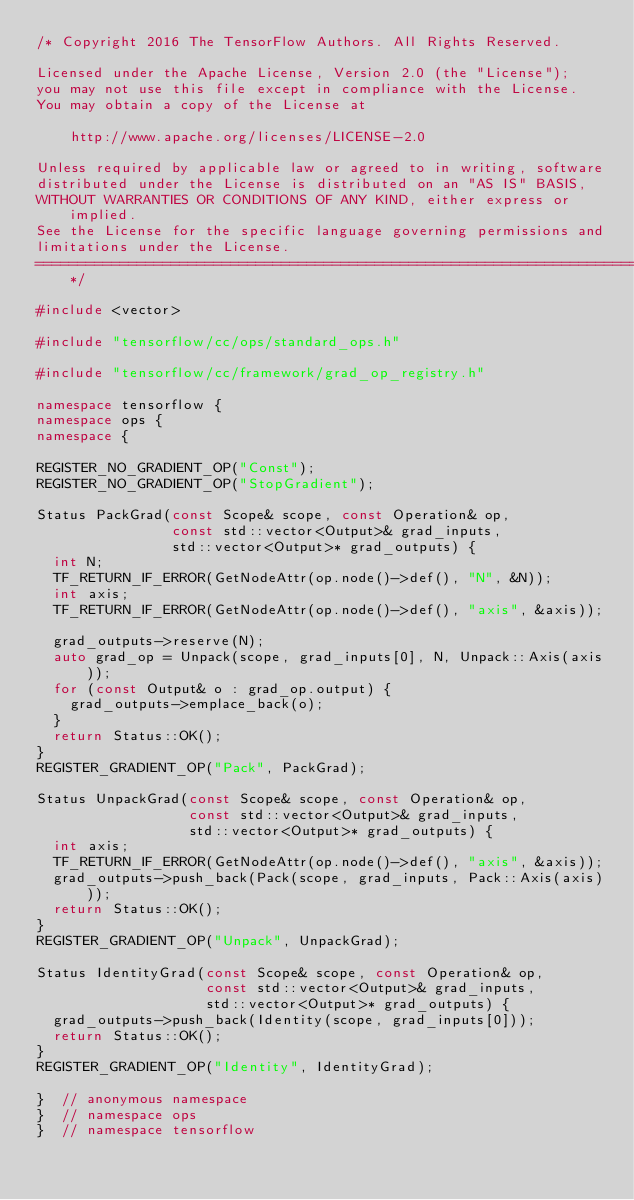<code> <loc_0><loc_0><loc_500><loc_500><_C++_>/* Copyright 2016 The TensorFlow Authors. All Rights Reserved.

Licensed under the Apache License, Version 2.0 (the "License");
you may not use this file except in compliance with the License.
You may obtain a copy of the License at

    http://www.apache.org/licenses/LICENSE-2.0

Unless required by applicable law or agreed to in writing, software
distributed under the License is distributed on an "AS IS" BASIS,
WITHOUT WARRANTIES OR CONDITIONS OF ANY KIND, either express or implied.
See the License for the specific language governing permissions and
limitations under the License.
==============================================================================*/

#include <vector>

#include "tensorflow/cc/ops/standard_ops.h"

#include "tensorflow/cc/framework/grad_op_registry.h"

namespace tensorflow {
namespace ops {
namespace {

REGISTER_NO_GRADIENT_OP("Const");
REGISTER_NO_GRADIENT_OP("StopGradient");

Status PackGrad(const Scope& scope, const Operation& op,
                const std::vector<Output>& grad_inputs,
                std::vector<Output>* grad_outputs) {
  int N;
  TF_RETURN_IF_ERROR(GetNodeAttr(op.node()->def(), "N", &N));
  int axis;
  TF_RETURN_IF_ERROR(GetNodeAttr(op.node()->def(), "axis", &axis));

  grad_outputs->reserve(N);
  auto grad_op = Unpack(scope, grad_inputs[0], N, Unpack::Axis(axis));
  for (const Output& o : grad_op.output) {
    grad_outputs->emplace_back(o);
  }
  return Status::OK();
}
REGISTER_GRADIENT_OP("Pack", PackGrad);

Status UnpackGrad(const Scope& scope, const Operation& op,
                  const std::vector<Output>& grad_inputs,
                  std::vector<Output>* grad_outputs) {
  int axis;
  TF_RETURN_IF_ERROR(GetNodeAttr(op.node()->def(), "axis", &axis));
  grad_outputs->push_back(Pack(scope, grad_inputs, Pack::Axis(axis)));
  return Status::OK();
}
REGISTER_GRADIENT_OP("Unpack", UnpackGrad);

Status IdentityGrad(const Scope& scope, const Operation& op,
                    const std::vector<Output>& grad_inputs,
                    std::vector<Output>* grad_outputs) {
  grad_outputs->push_back(Identity(scope, grad_inputs[0]));
  return Status::OK();
}
REGISTER_GRADIENT_OP("Identity", IdentityGrad);

}  // anonymous namespace
}  // namespace ops
}  // namespace tensorflow
</code> 